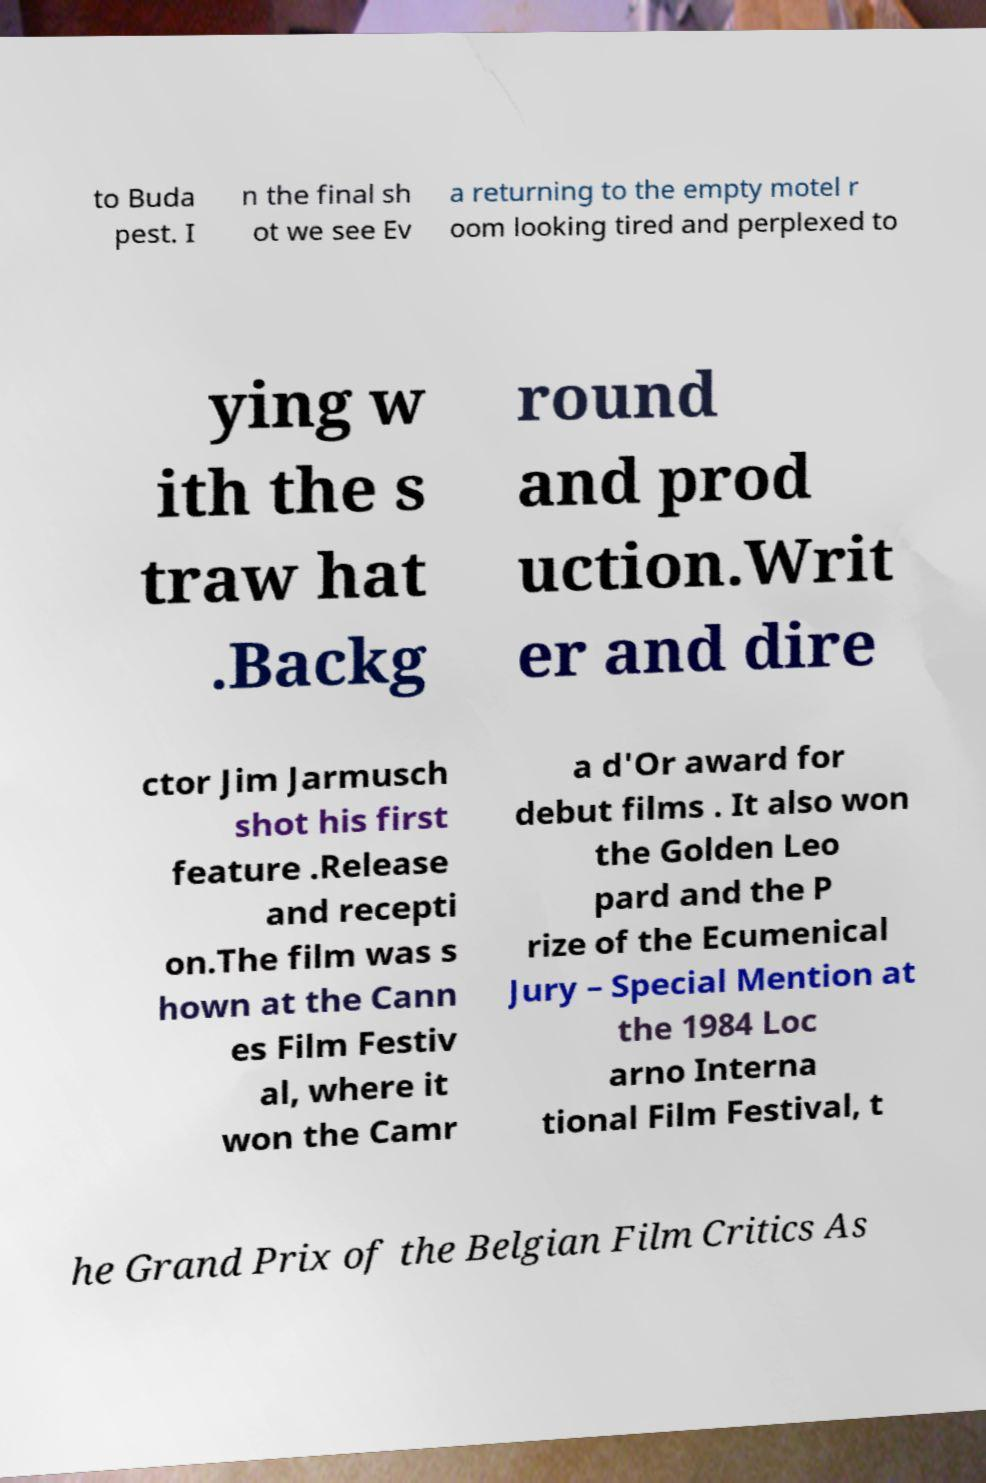Can you accurately transcribe the text from the provided image for me? to Buda pest. I n the final sh ot we see Ev a returning to the empty motel r oom looking tired and perplexed to ying w ith the s traw hat .Backg round and prod uction.Writ er and dire ctor Jim Jarmusch shot his first feature .Release and recepti on.The film was s hown at the Cann es Film Festiv al, where it won the Camr a d'Or award for debut films . It also won the Golden Leo pard and the P rize of the Ecumenical Jury – Special Mention at the 1984 Loc arno Interna tional Film Festival, t he Grand Prix of the Belgian Film Critics As 